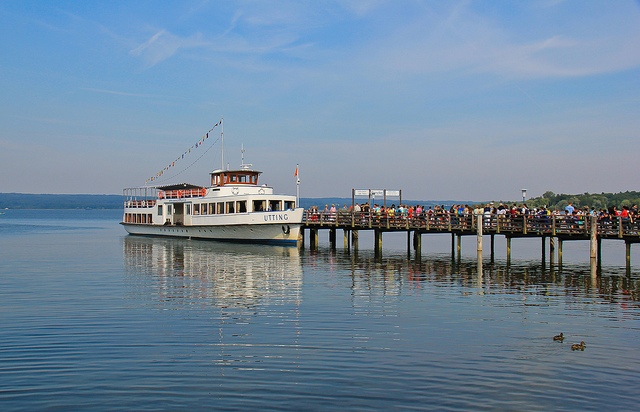<image>What city is on the side of the boat? It is unknown what city is on the side of the boat as it is not visible. Which of these boats appears ready to be used on a fishing trip? I am not sure which boat appears ready to be used on a fishing trip. It could be the 'big white one' or 'large' one. What city is on the side of the boat? I don't know what city is on the side of the boat. It is not visible in the image. Which of these boats appears ready to be used on a fishing trip? I don't know which of these boats appears ready to be used on a fishing trip. It is not clear from the information given. 